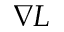<formula> <loc_0><loc_0><loc_500><loc_500>\nabla L</formula> 